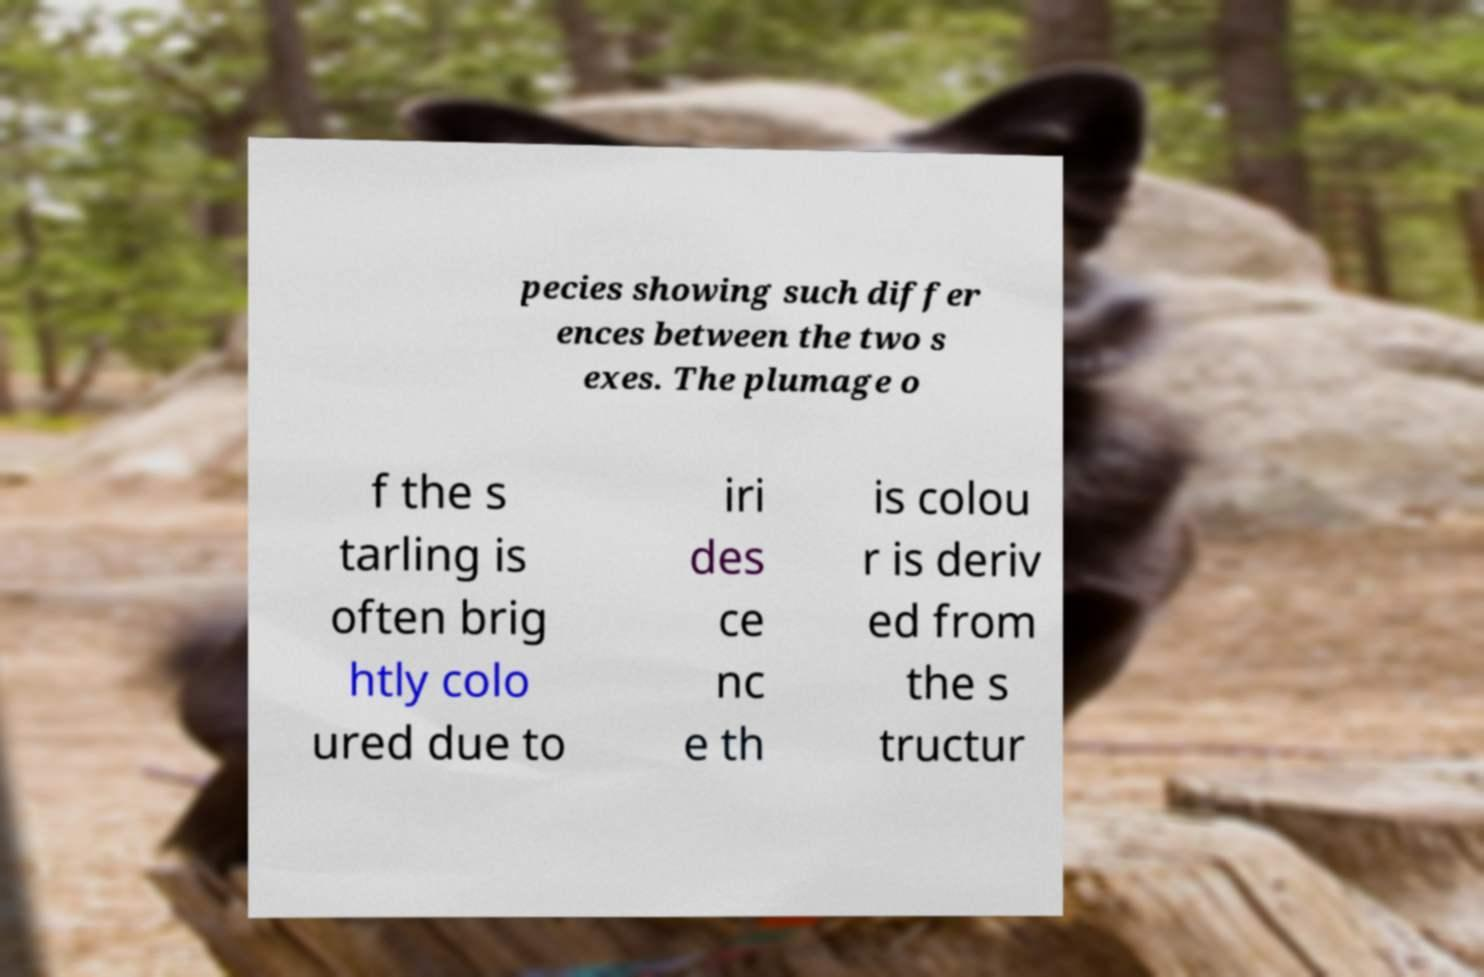Can you accurately transcribe the text from the provided image for me? pecies showing such differ ences between the two s exes. The plumage o f the s tarling is often brig htly colo ured due to iri des ce nc e th is colou r is deriv ed from the s tructur 